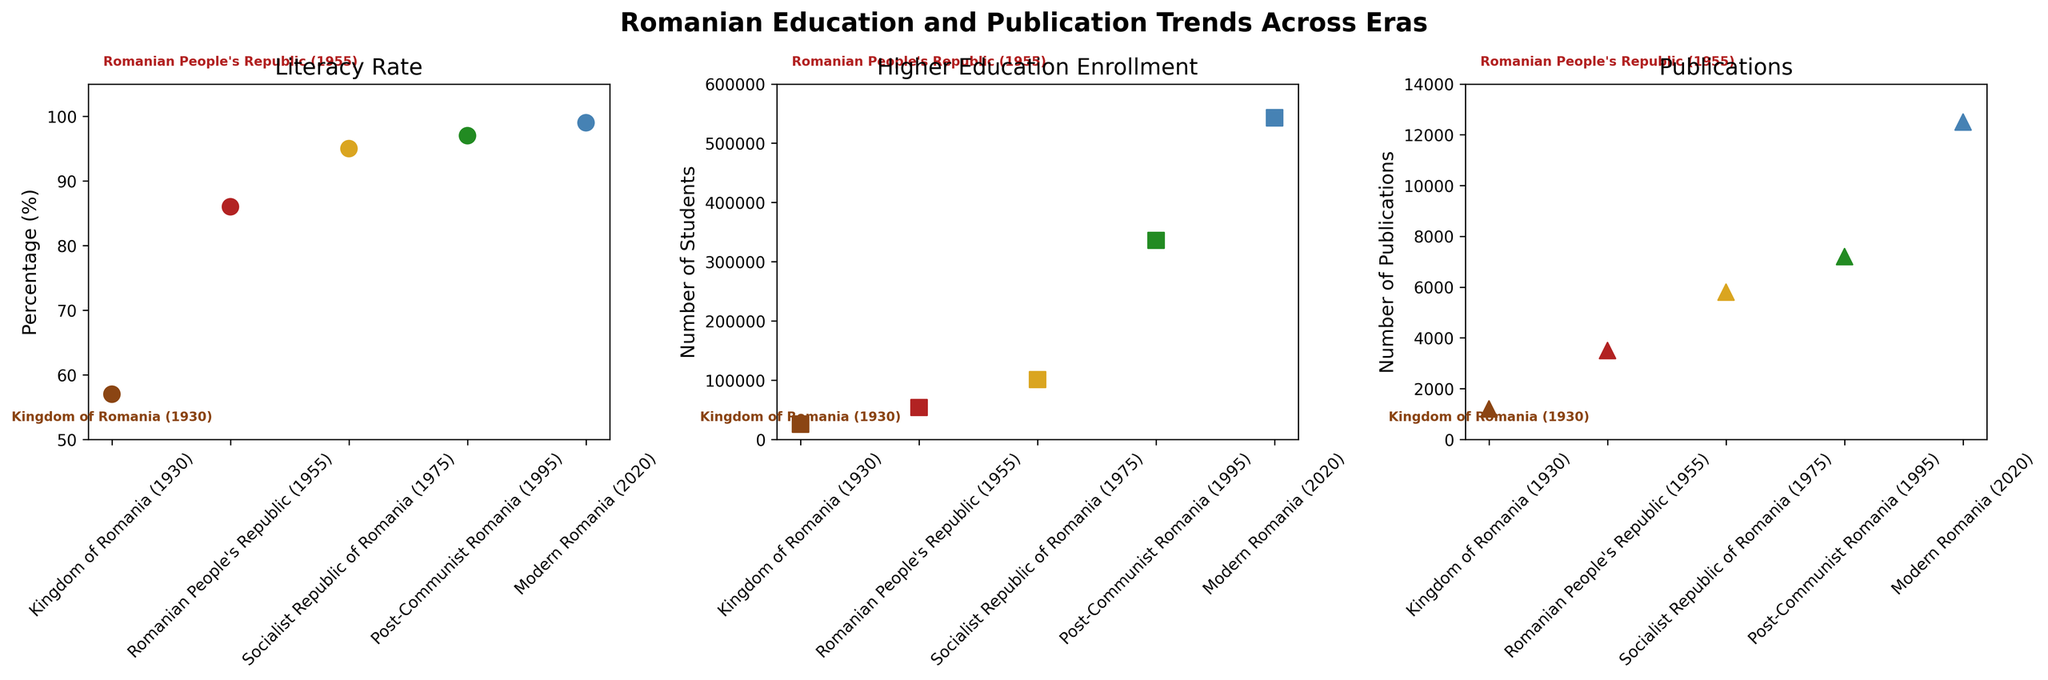What is the title of the figure? The title of the figure is located at the top of the subplot and reads: "Romanian Education and Publication Trends Across Eras".
Answer: Romanian Education and Publication Trends Across Eras How many eras are compared in the figure? The figure shows five different eras, which can be counted by looking at the x-axis labels of each subplot: "Kingdom of Romania (1930)", "Romanian People's Republic (1955)", "Socialist Republic of Romania (1975)", "Post-Communist Romania (1995)", and "Modern Romania (2020)".
Answer: Five What is the literacy rate in the Kingdom of Romania (1930)? The literacy rate for the Kingdom of Romania (1930) can be found by looking at the first subplot for Literacy Rate where the value associated with the "Kingdom of Romania (1930)" data point is 57%.
Answer: 57% Which era has the highest number of higher education enrollments? The highest number of higher education enrollments can be identified in the "Modern Romania (2020)" era by looking at the second subplot.
Answer: Modern Romania (2020) What is the difference in the number of publications between the Socialist Republic of Romania (1975) and Post-Communist Romania (1995)? From the third subplot, the number of publications in 1975 is 5800 and in 1995 is 7200. The difference can be calculated as 7200 - 5800 = 1400.
Answer: 1400 How much did the literacy rate increase from the Kingdom of Romania (1930) to the Romanian People's Republic (1955)? The literacy rate in 1930 was 57% and in 1955 was 86%. The increase can be calculated as 86% - 57% = 29%.
Answer: 29% Is there any era where the literacy rate does not show any improvement over the previous era? By examining the first subplot, we see that the literacy rate increases continuously from 57% to 99% across all eras. There is no era where the literacy rate does not show improvement.
Answer: No Which era saw the largest increase in higher education enrollment compared to the previous era? Comparing the values in the second subplot, the largest increase is between "Post-Communist Romania (1995)" with 336,000 enrollments and "Socialist Republic of Romania (1975)" with 101,000 enrollments. The increase is 336,000 - 101,000 = 235,000.
Answer: The increase between 1975 and 1995 What can be inferred about the trend in the number of publications from 1930 to 2020? Observing the third subplot, the number of publications consistently increases from 1200 in 1930 to 12500 in 2020, indicating a positive trend in scientific output over time.
Answer: A consistent increase What was the approximate percentage increase in literacy rate from the Romanian People's Republic (1955) to Modern Romania (2020)? The literacy rate in 1955 was 86% and in 2020 it is 99%. The percentage increase is calculated as ((99 - 86) / 86) * 100% = 15.12%.
Answer: 15.12% 